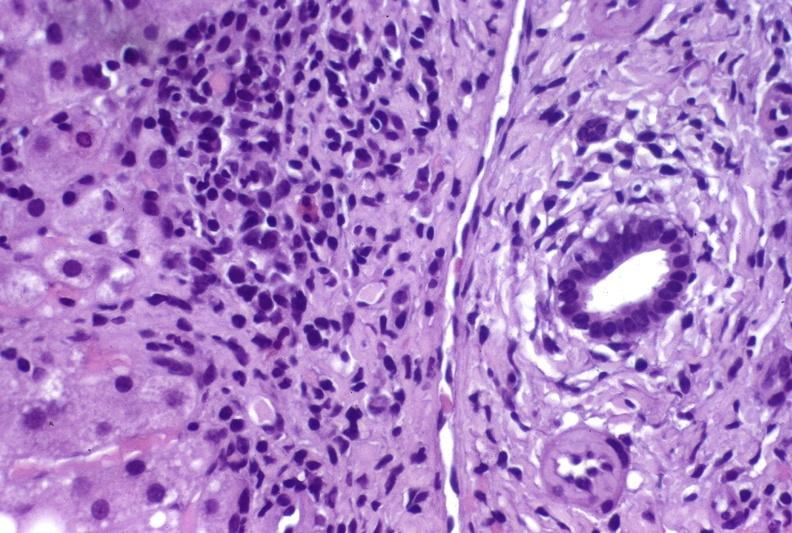does this image show hepatitis c virus?
Answer the question using a single word or phrase. Yes 